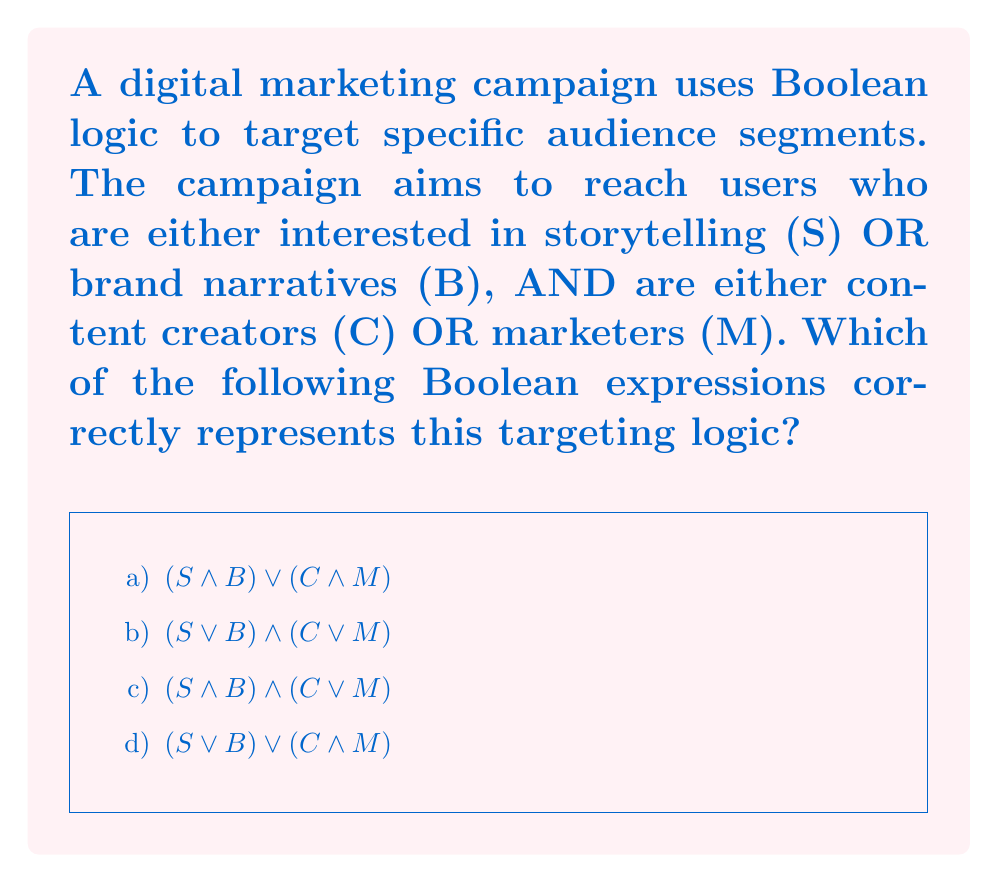Provide a solution to this math problem. To solve this problem, let's break down the targeting logic and translate it into Boolean algebra:

1. Users interested in storytelling (S) OR brand narratives (B):
   This is represented as $(S \lor B)$

2. Users who are content creators (C) OR marketers (M):
   This is represented as $(C \lor M)$

3. The campaign wants to target users who meet BOTH of these criteria:
   This means we need to use the AND operator ($\land$) to combine the two conditions.

Putting it all together, we get:

$$(S \lor B) \land (C \lor M)$$

This expression means:
(Interested in storytelling OR brand narratives) AND (Is a content creator OR marketer)

Now, let's evaluate each option:

a) $(S \land B) \lor (C \land M)$
   This would target users interested in BOTH storytelling AND brand narratives, OR users who are BOTH content creators AND marketers. This is too restrictive and doesn't match the desired logic.

b) $(S \lor B) \land (C \lor M)$
   This correctly represents the targeting logic as explained above.

c) $(S \land B) \land (C \lor M)$
   This would target users interested in BOTH storytelling AND brand narratives, which is more restrictive than the desired logic.

d) $(S \lor B) \lor (C \land M)$
   This would target users interested in either storytelling OR brand narratives, OR users who are BOTH content creators AND marketers. This is too broad and doesn't match the desired logic.

Therefore, the correct answer is option b.
Answer: b) $(S \lor B) \land (C \lor M)$ 